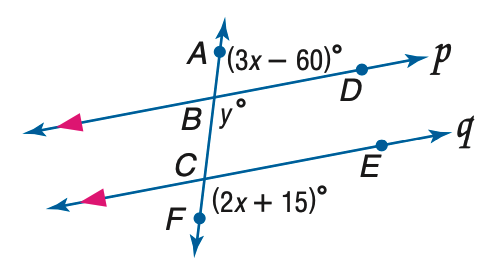Answer the mathemtical geometry problem and directly provide the correct option letter.
Question: Refer to the figure at the right. Find the value of m \angle A B D if p \parallel q.
Choices: A: 65 B: 70 C: 75 D: 80 C 